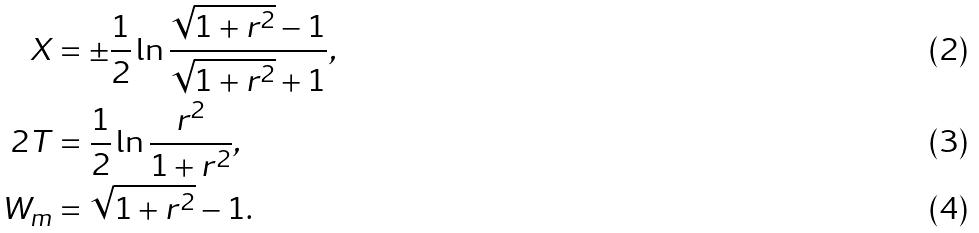Convert formula to latex. <formula><loc_0><loc_0><loc_500><loc_500>X & = \pm \frac { 1 } { 2 } \ln \frac { \sqrt { 1 + r ^ { 2 } } - 1 } { \sqrt { 1 + r ^ { 2 } } + 1 } , \\ 2 T & = \frac { 1 } { 2 } \ln \frac { r ^ { 2 } } { 1 + r ^ { 2 } } , \\ W _ { m } & = \sqrt { 1 + r ^ { 2 } } - 1 .</formula> 